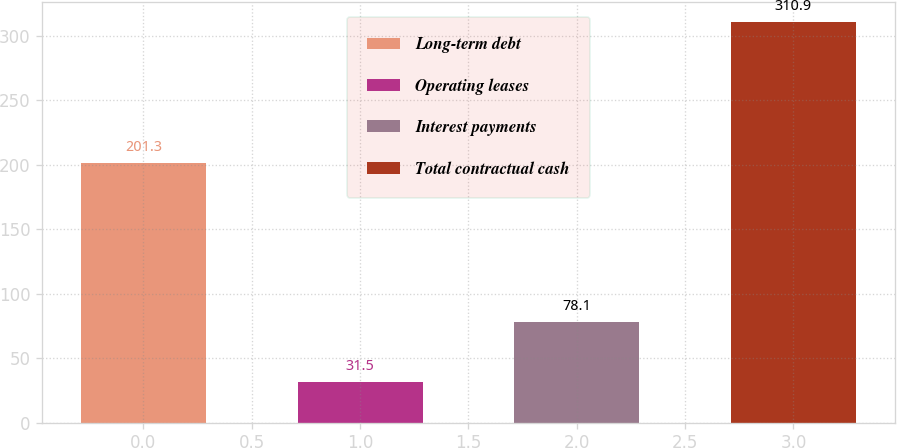Convert chart to OTSL. <chart><loc_0><loc_0><loc_500><loc_500><bar_chart><fcel>Long-term debt<fcel>Operating leases<fcel>Interest payments<fcel>Total contractual cash<nl><fcel>201.3<fcel>31.5<fcel>78.1<fcel>310.9<nl></chart> 